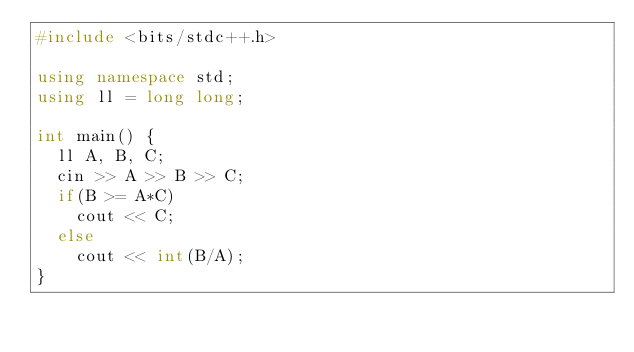Convert code to text. <code><loc_0><loc_0><loc_500><loc_500><_C++_>#include <bits/stdc++.h>

using namespace std;
using ll = long long;

int main() {
  ll A, B, C;
  cin >> A >> B >> C;
  if(B >= A*C)
    cout << C;
  else
    cout << int(B/A);
}
</code> 